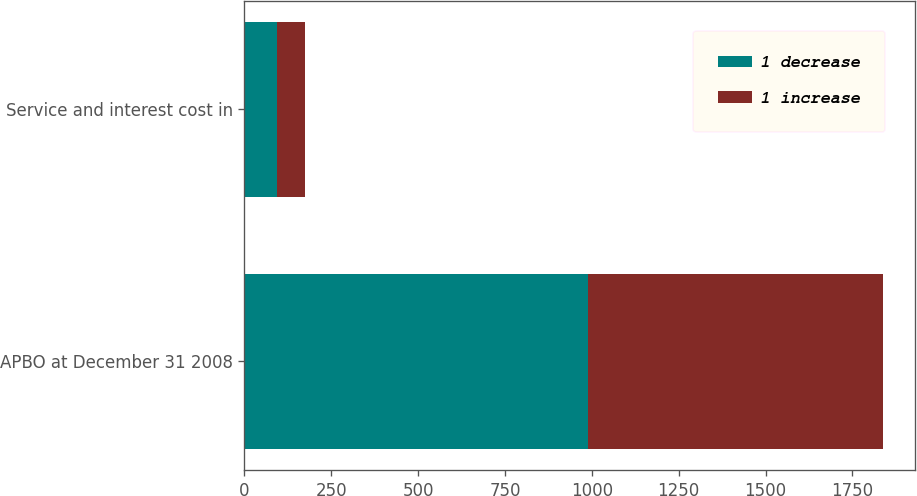Convert chart. <chart><loc_0><loc_0><loc_500><loc_500><stacked_bar_chart><ecel><fcel>APBO at December 31 2008<fcel>Service and interest cost in<nl><fcel>1 decrease<fcel>990<fcel>95<nl><fcel>1 increase<fcel>848<fcel>80<nl></chart> 